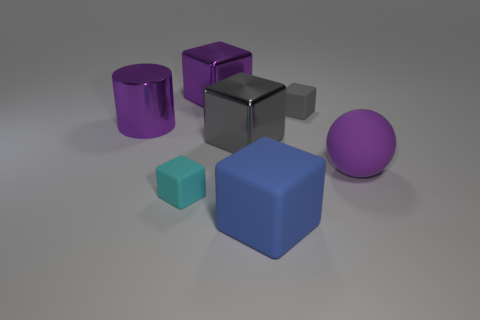What is the color of the large cylinder?
Your answer should be compact. Purple. Does the cylinder have the same material as the gray block on the left side of the blue rubber cube?
Keep it short and to the point. Yes. The purple thing that is made of the same material as the small cyan block is what shape?
Offer a terse response. Sphere. What color is the matte ball that is the same size as the purple block?
Provide a short and direct response. Purple. There is a cyan rubber object that is behind the blue block; does it have the same size as the purple cylinder?
Your response must be concise. No. Is the big sphere the same color as the large metallic cylinder?
Your answer should be compact. Yes. How many big balls are there?
Provide a short and direct response. 1. How many cubes are big shiny things or large gray objects?
Your answer should be very brief. 2. How many gray things are left of the small object that is behind the gray metallic object?
Provide a short and direct response. 1. Are the small cyan block and the big purple block made of the same material?
Your response must be concise. No. 